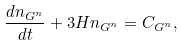<formula> <loc_0><loc_0><loc_500><loc_500>\frac { d n _ { G ^ { n } } } { d t } + 3 H n _ { G ^ { n } } = C _ { G ^ { n } } ,</formula> 